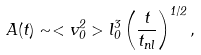Convert formula to latex. <formula><loc_0><loc_0><loc_500><loc_500>A ( t ) \sim < v _ { 0 } ^ { 2 } > l _ { 0 } ^ { 3 } \left ( \frac { t } { t _ { n l } } \right ) ^ { 1 / 2 } ,</formula> 